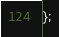Convert code to text. <code><loc_0><loc_0><loc_500><loc_500><_JavaScript_>};
</code> 